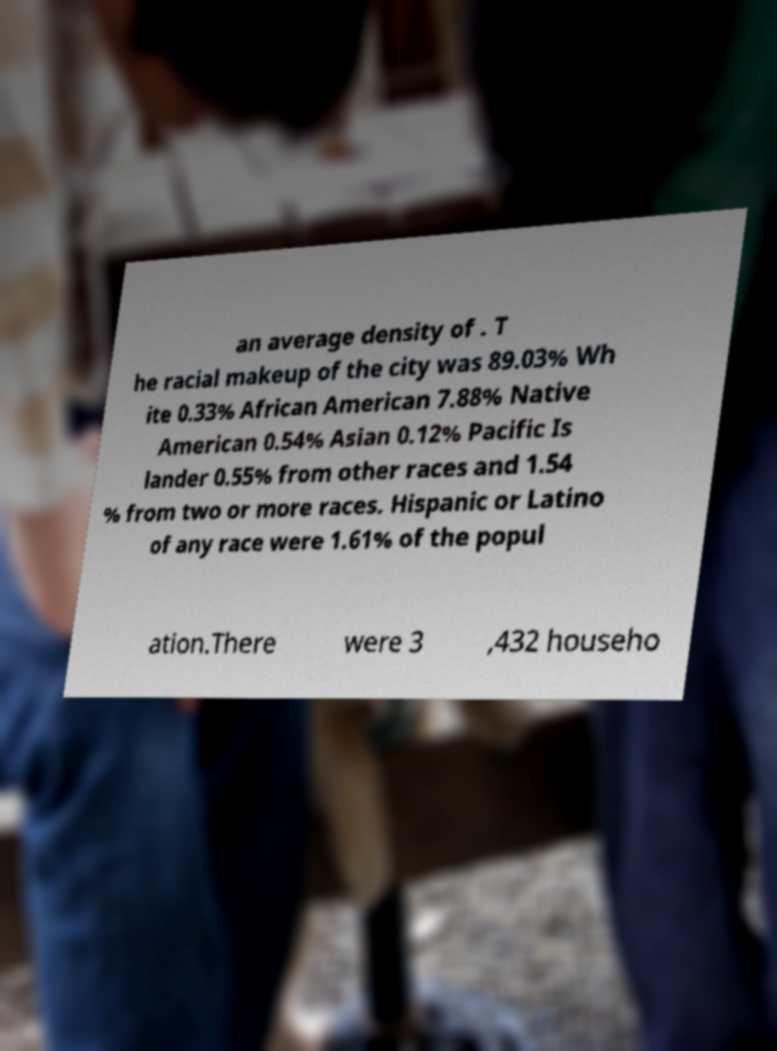I need the written content from this picture converted into text. Can you do that? an average density of . T he racial makeup of the city was 89.03% Wh ite 0.33% African American 7.88% Native American 0.54% Asian 0.12% Pacific Is lander 0.55% from other races and 1.54 % from two or more races. Hispanic or Latino of any race were 1.61% of the popul ation.There were 3 ,432 househo 